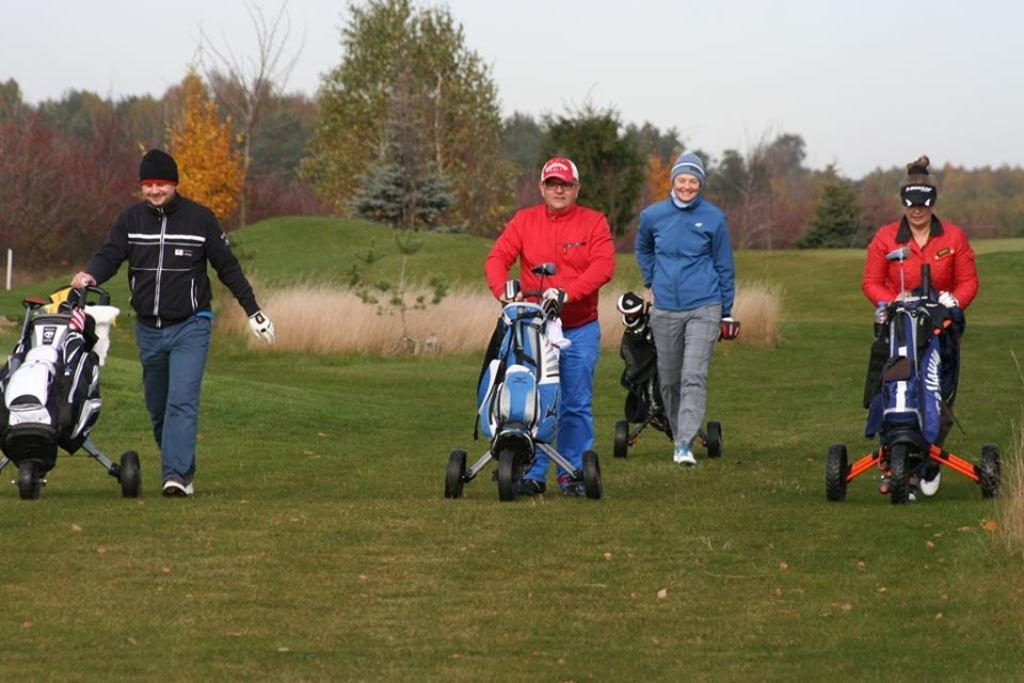What are the persons in the image doing? The persons in the image are pushing carts. What can be seen in the background of the image? There are trees in the background of the image. What is visible at the top of the image? The sky is visible at the top of the image. What type of reward is hanging from the carts in the image? There is no reward hanging from the carts in the image; the persons are simply pushing them. 